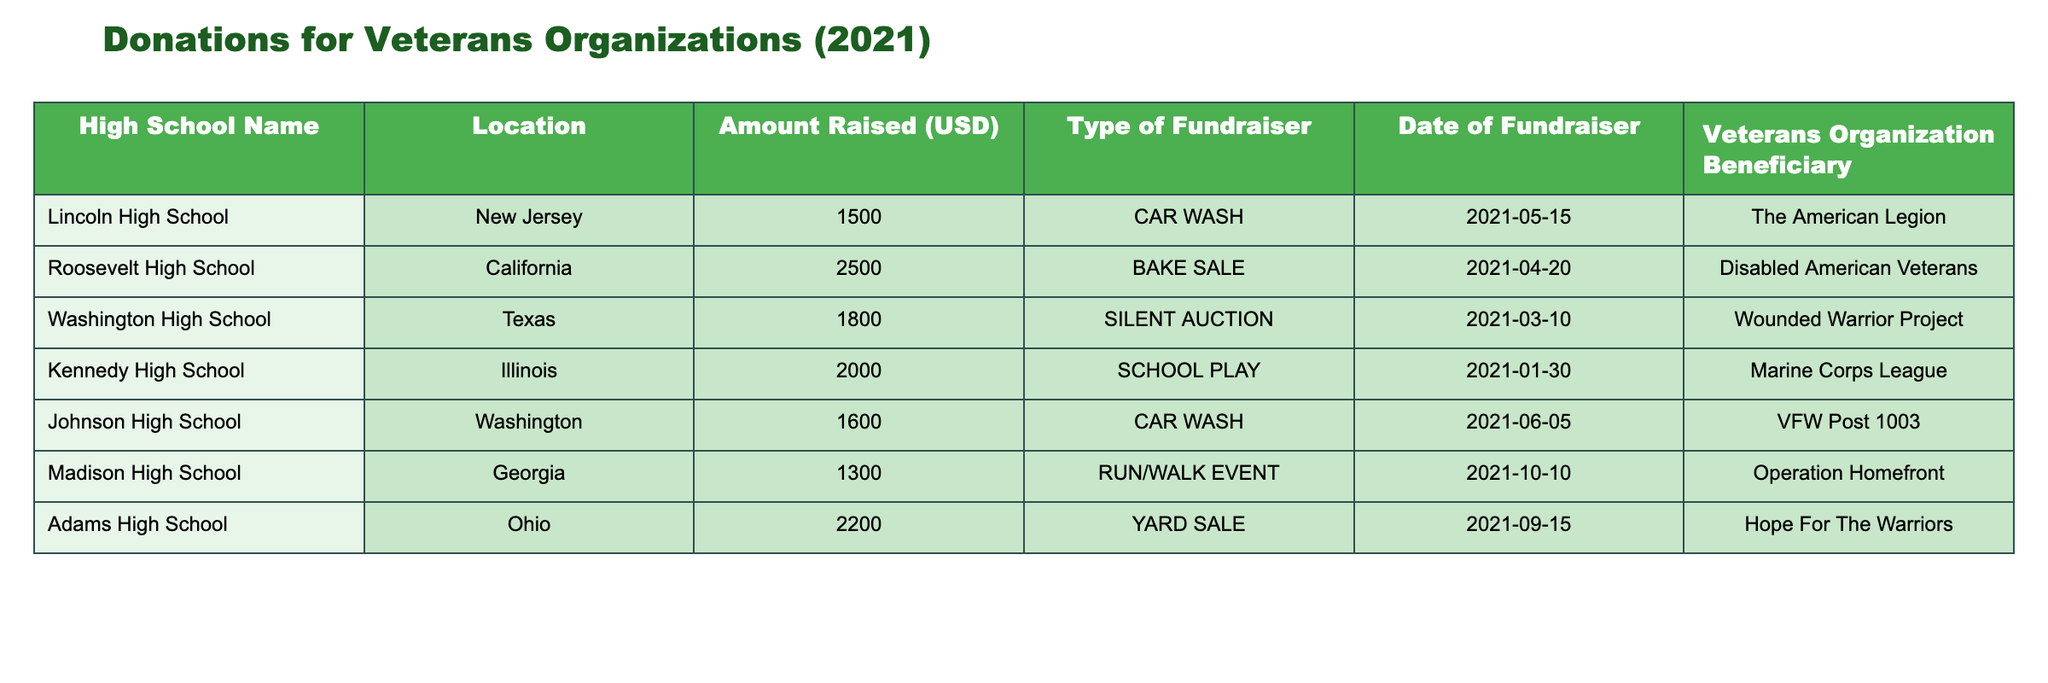What was the highest amount raised by a single high school? The amounts raised are listed in the table, and by scanning through those values, Lincoln High School raised 2500 USD, which is the highest among all entries.
Answer: 2500 USD Which veterans organization received funds from the majority of high schools? By examining the table, we find that The American Legion was chosen by only one high school, while all other organizations also received support from one high school each. Therefore, there is no single organization that received funds from the majority of high schools as all were represented by one school only.
Answer: No organization received funds from the majority What is the total amount raised by all high schools combined? To find the total amount raised, we sum all the individual amounts: 1500 + 2500 + 1800 + 2000 + 1600 + 1300 + 2200 = 12900 USD. This is simply adding together the amounts found in the 'Amount Raised' column.
Answer: 12900 USD Which type of fundraiser raised the most money? By categorizing the amounts by type of fundraiser, we can see: Car Wash (3100 USD), Bake Sale (2500 USD), Silent Auction (1800 USD), School Play (2000 USD), Run/Walk Event (1300 USD), Yard Sale (2200 USD). The highest total is from Car Wash, which raised 3100 USD combined from Lincoln and Johnson High Schools.
Answer: Car Wash Did any high school fundraisers occur in the first half of 2021? Observing the dates, Kennedy High School raised funds on January 30 and Washington High School on March 10. Since both of these dates fall in the first half of the year, the answer is yes.
Answer: Yes 